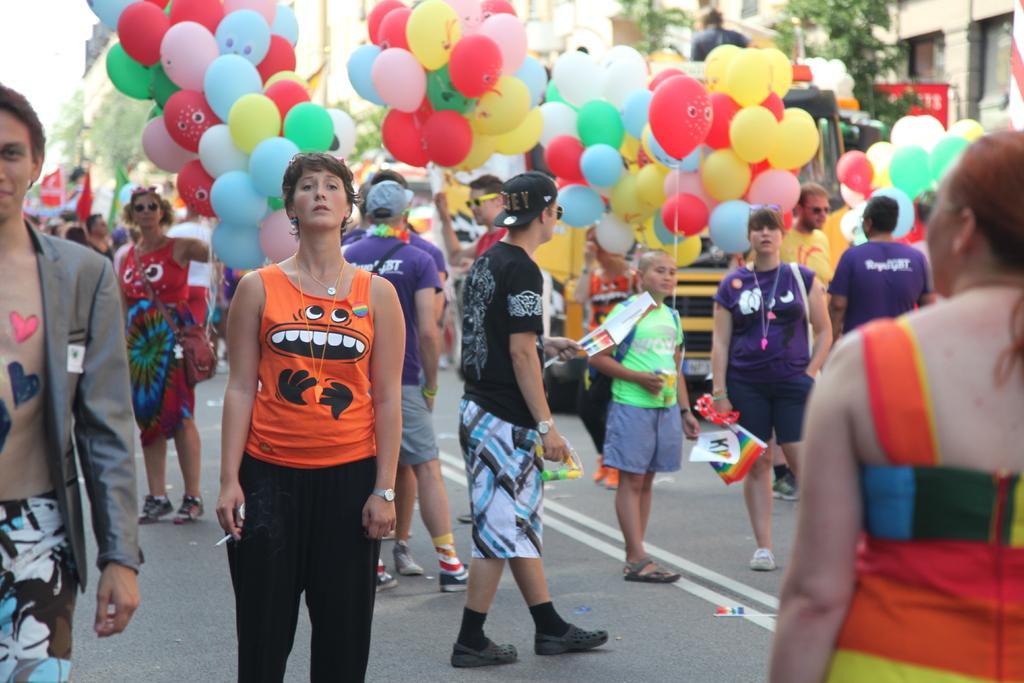Describe this image in one or two sentences. In this image we can see some people standing and we can also see some people holding balloons. 